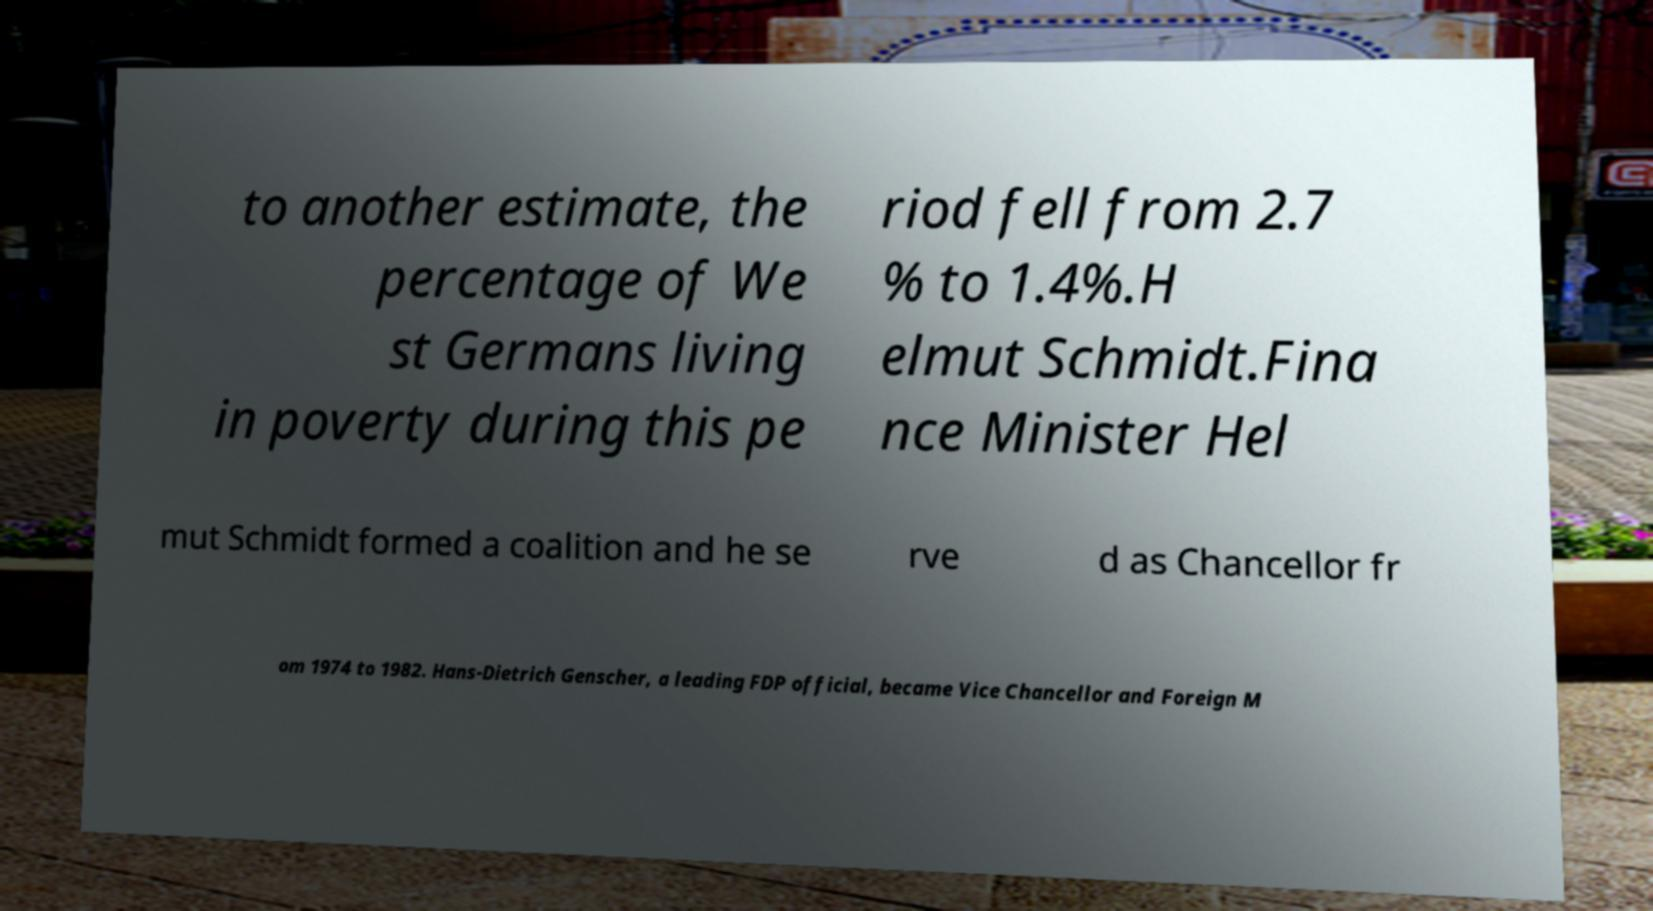Please read and relay the text visible in this image. What does it say? to another estimate, the percentage of We st Germans living in poverty during this pe riod fell from 2.7 % to 1.4%.H elmut Schmidt.Fina nce Minister Hel mut Schmidt formed a coalition and he se rve d as Chancellor fr om 1974 to 1982. Hans-Dietrich Genscher, a leading FDP official, became Vice Chancellor and Foreign M 